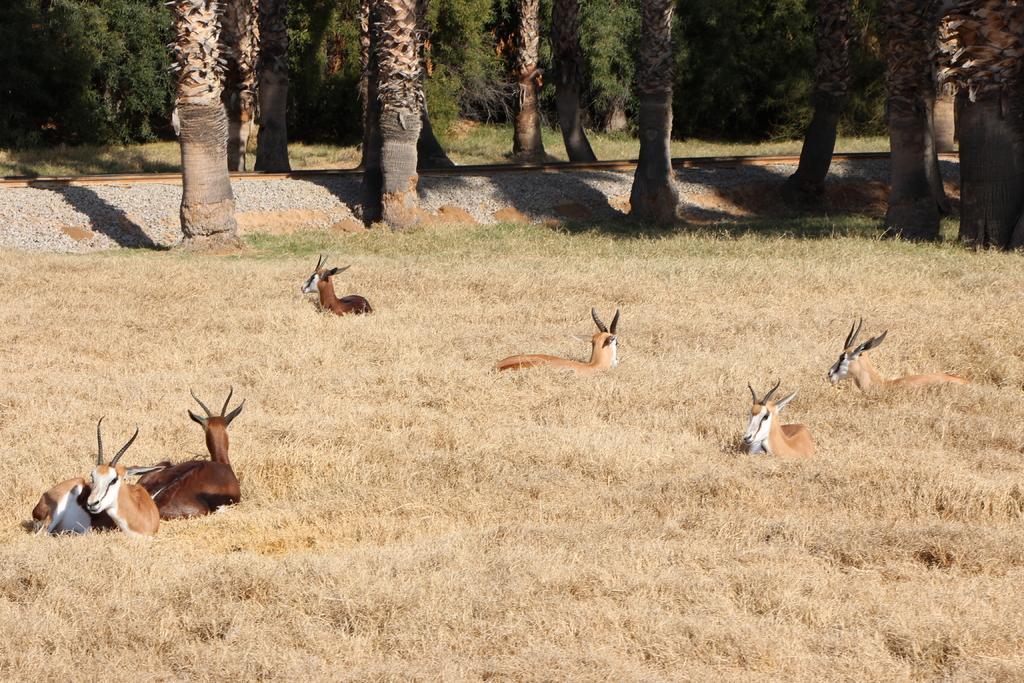How would you summarize this image in a sentence or two? In this picture we can see few animals and dried grass, in the background we can find few trees and stones. 